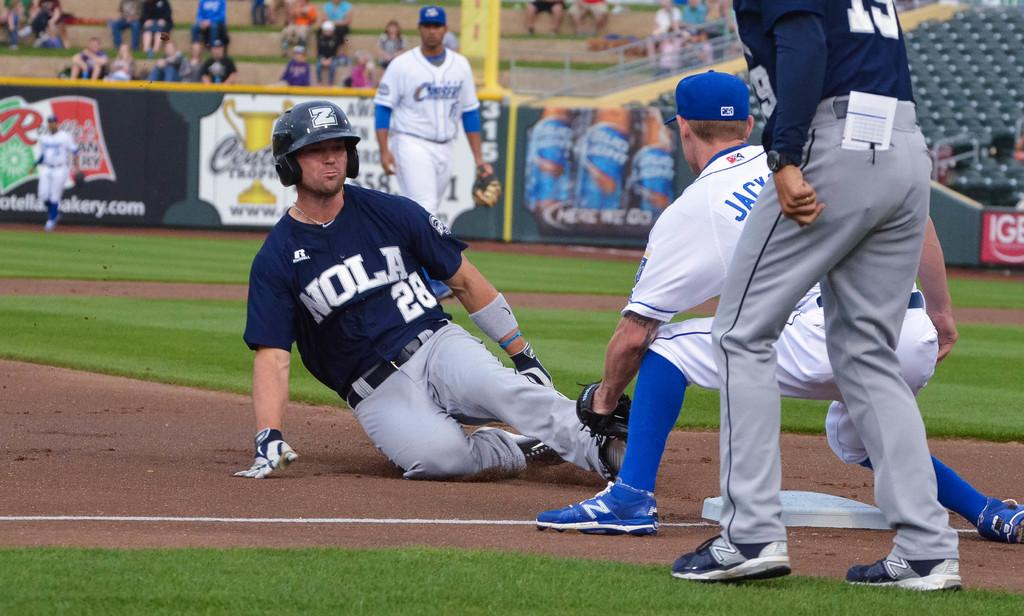Provide a one-sentence caption for the provided image. A baseball games with player 28 sliding into a base. 